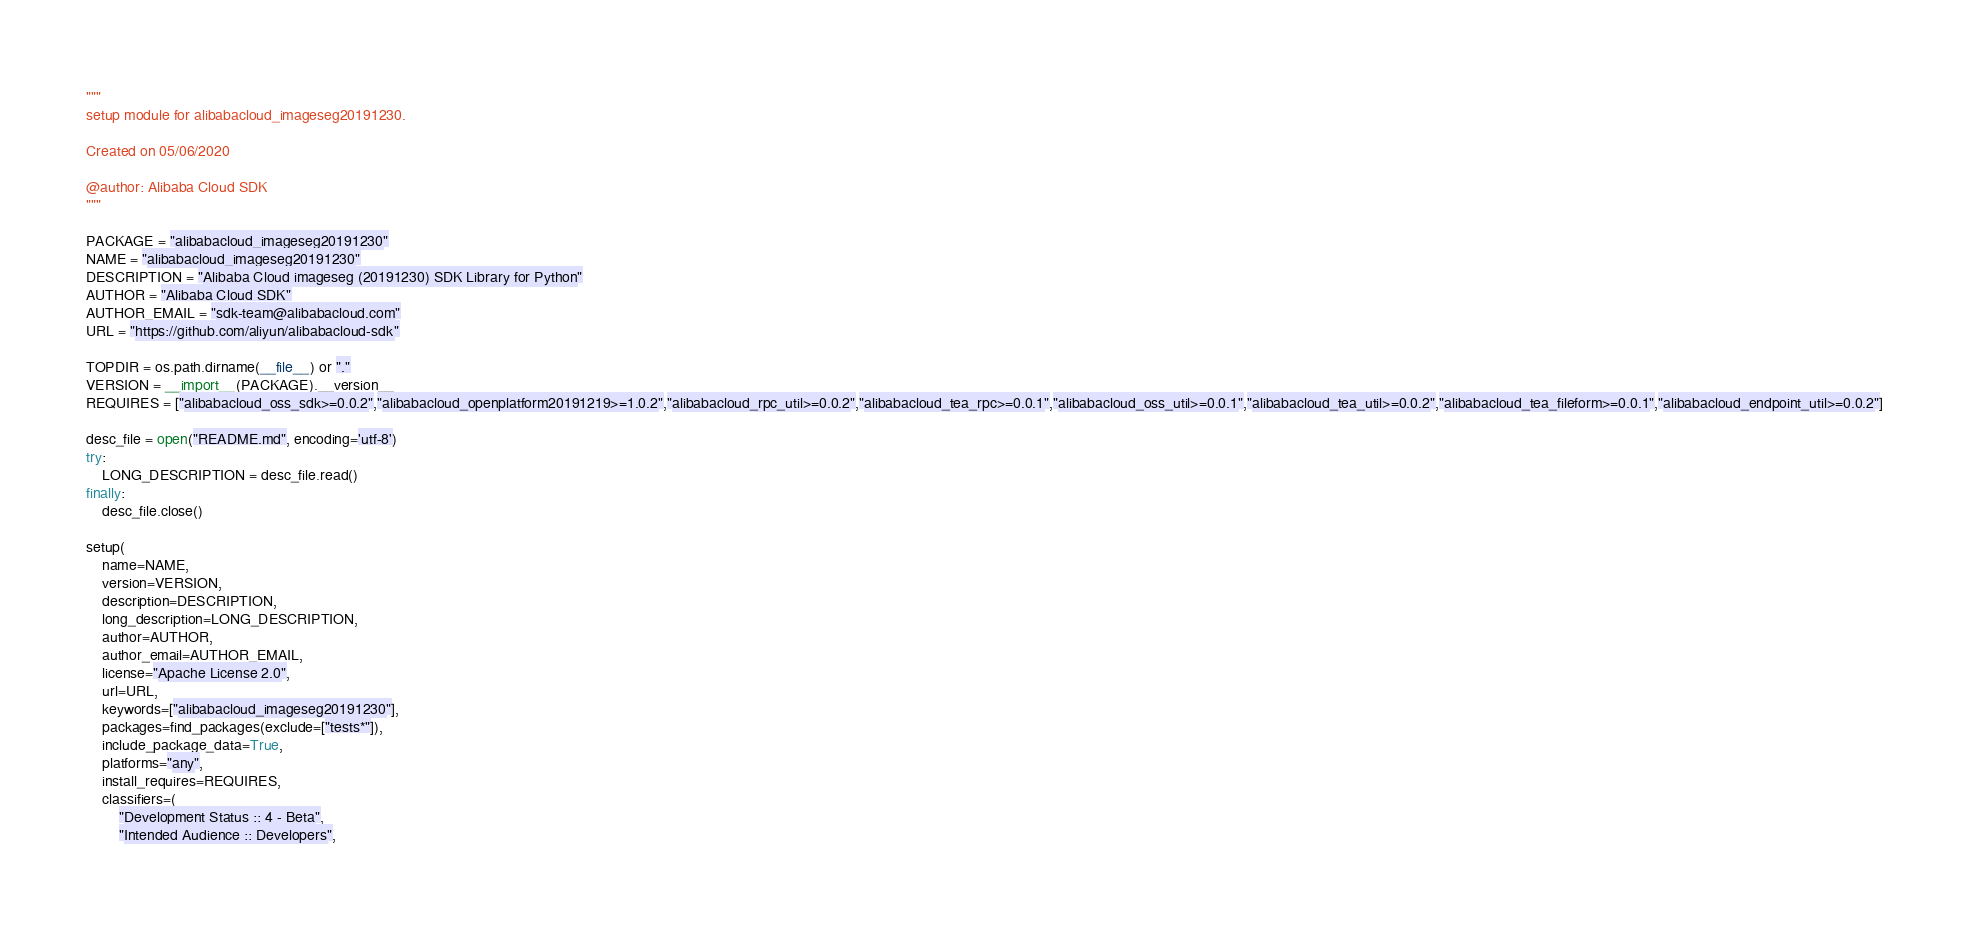Convert code to text. <code><loc_0><loc_0><loc_500><loc_500><_Python_>"""
setup module for alibabacloud_imageseg20191230.

Created on 05/06/2020

@author: Alibaba Cloud SDK
"""

PACKAGE = "alibabacloud_imageseg20191230"
NAME = "alibabacloud_imageseg20191230"
DESCRIPTION = "Alibaba Cloud imageseg (20191230) SDK Library for Python"
AUTHOR = "Alibaba Cloud SDK"
AUTHOR_EMAIL = "sdk-team@alibabacloud.com"
URL = "https://github.com/aliyun/alibabacloud-sdk"

TOPDIR = os.path.dirname(__file__) or "."
VERSION = __import__(PACKAGE).__version__
REQUIRES = ["alibabacloud_oss_sdk>=0.0.2","alibabacloud_openplatform20191219>=1.0.2","alibabacloud_rpc_util>=0.0.2","alibabacloud_tea_rpc>=0.0.1","alibabacloud_oss_util>=0.0.1","alibabacloud_tea_util>=0.0.2","alibabacloud_tea_fileform>=0.0.1","alibabacloud_endpoint_util>=0.0.2"]

desc_file = open("README.md", encoding='utf-8')
try:
    LONG_DESCRIPTION = desc_file.read()
finally:
    desc_file.close()

setup(
    name=NAME,
    version=VERSION,
    description=DESCRIPTION,
    long_description=LONG_DESCRIPTION,
    author=AUTHOR,
    author_email=AUTHOR_EMAIL,
    license="Apache License 2.0",
    url=URL,
    keywords=["alibabacloud_imageseg20191230"],
    packages=find_packages(exclude=["tests*"]),
    include_package_data=True,
    platforms="any",
    install_requires=REQUIRES,
    classifiers=(
        "Development Status :: 4 - Beta",
        "Intended Audience :: Developers",</code> 